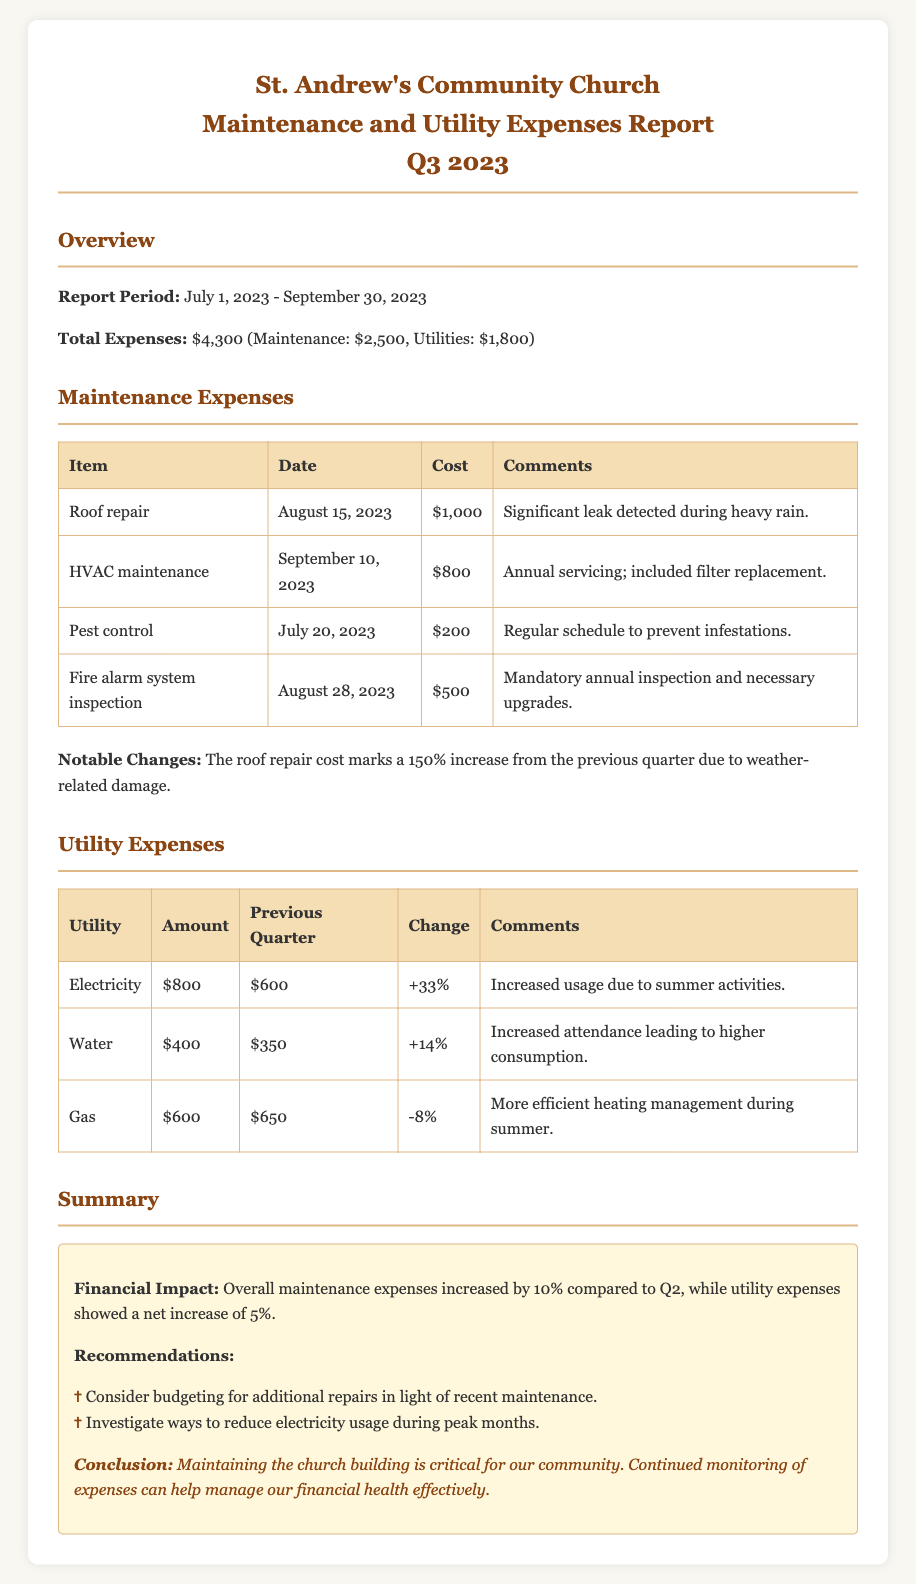What is the total expense for maintenance in Q3 2023? The total expense for maintenance is explicitly mentioned in the document as $2,500.
Answer: $2,500 What caused the significant increase in maintenance costs? The document states that the roof repair cost marks a 150% increase from the previous quarter due to weather-related damage.
Answer: Weather-related damage What is the total utility expense for Q3 2023? The total utility expense is listed in the document as $1,800.
Answer: $1,800 By what percentage did electricity expenses increase from the previous quarter? The document mentions that electricity expenses increased by 33% as compared to the previous quarter.
Answer: 33% What was the cost for the fire alarm system inspection? The document provides the cost for the fire alarm system inspection as $500.
Answer: $500 What is the primary reason for the increase in water expenses? The document notes that the primary reason for increased water expenses is higher consumption due to increased attendance.
Answer: Higher consumption What is the overall percentage increase in maintenance expenses compared to Q2? The document states that overall maintenance expenses increased by 10% compared to Q2.
Answer: 10% What are the recommendations made in the report? The document lists two recommendations: budgeting for additional repairs and investigating ways to reduce electricity usage.
Answer: Budgeting for additional repairs; reduce electricity usage What was the total expense for utilities in Q3 2023? The document clearly states that the total expenses for utilities amount to $1,800.
Answer: $1,800 